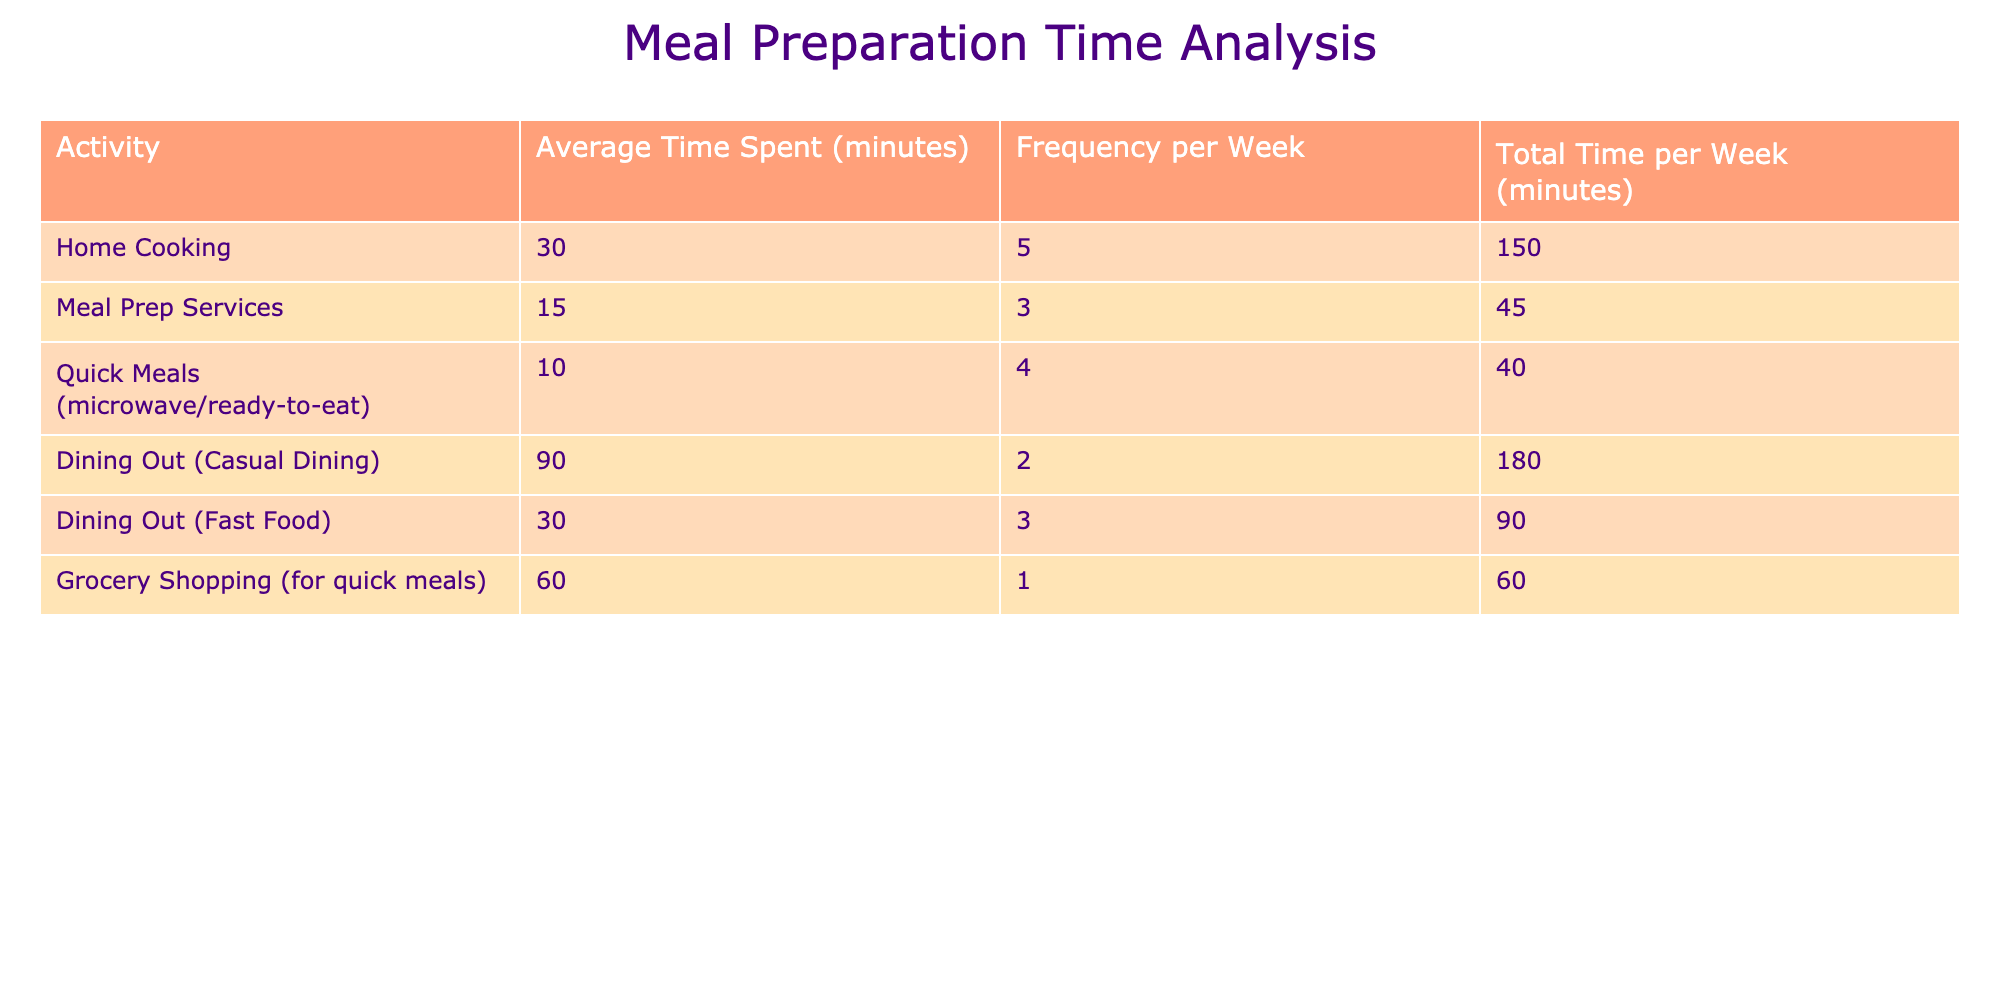What is the average time spent on home cooking per week? The average time spent on home cooking is 30 minutes, and it occurs 5 times a week. To find the total time spent per week, we multiply 30 by 5, which equals 150 minutes.
Answer: 150 minutes How much time do you spend dining out in total per week? There are two dining out categories: casual dining (2 times a week at 90 minutes each) and fast food (3 times at 30 minutes each). The total for casual dining is 90 times 2, which equals 180 minutes. The total for fast food is 30 times 3, which equals 90 minutes. Summing these gives 180 + 90 = 270 minutes.
Answer: 270 minutes Which meal preparation activity takes the least amount of time on average? Looking at the table, meal prep services take 15 minutes on average, quick meals take 10 minutes, and fast food takes 30 minutes. Among these, quick meals have the smallest average time.
Answer: Quick Meals (10 minutes) Is the total time spent on casual dining more than that on home cooking? The total time for casual dining is 180 minutes, while the time spent on home cooking is 150 minutes. Since 180 is greater than 150, the statement is true.
Answer: Yes What is the total time spent on grocery shopping and meal prep services combined in minutes? Grocery shopping takes 60 minutes once a week, and meal prep services take 15 minutes 3 times a week (totaling 45 minutes). Adding these gives 60 + 45 = 105 minutes for both activities.
Answer: 105 minutes If you spend 2 hours on dining out over the week, how does that compare to your home cooking time? First, convert 2 hours into minutes, which is 120 minutes. Then add both casual and fast food dining totals together (270 minutes). The home cooking time is 150 minutes. Thus, dining out (270 minutes) is more than home cooking (150 minutes).
Answer: Dining out is more What is the difference in total minutes spent on dining out versus home cooking per week? We have already calculated total dining out (270 minutes) and home cooking (150 minutes). To find the difference, we subtract home cooking from dining out: 270 - 150 = 120 minutes.
Answer: 120 minutes Which meal preparation method requires more frequency per week, home cooking or quick meals? Home cooking occurs 5 times a week, whereas quick meals occur 4 times a week. Since 5 is greater than 4, home cooking is more frequent.
Answer: Home Cooking 